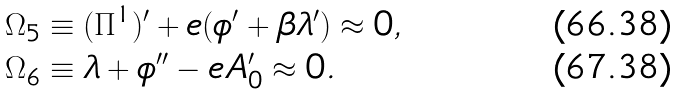<formula> <loc_0><loc_0><loc_500><loc_500>\Omega _ { 5 } & \equiv ( \Pi ^ { 1 } ) ^ { \prime } + e ( \phi ^ { \prime } + \beta \lambda ^ { \prime } ) \approx 0 , \\ \Omega _ { 6 } & \equiv \lambda + \phi ^ { \prime \prime } - e A ^ { \prime } _ { 0 } \approx 0 .</formula> 